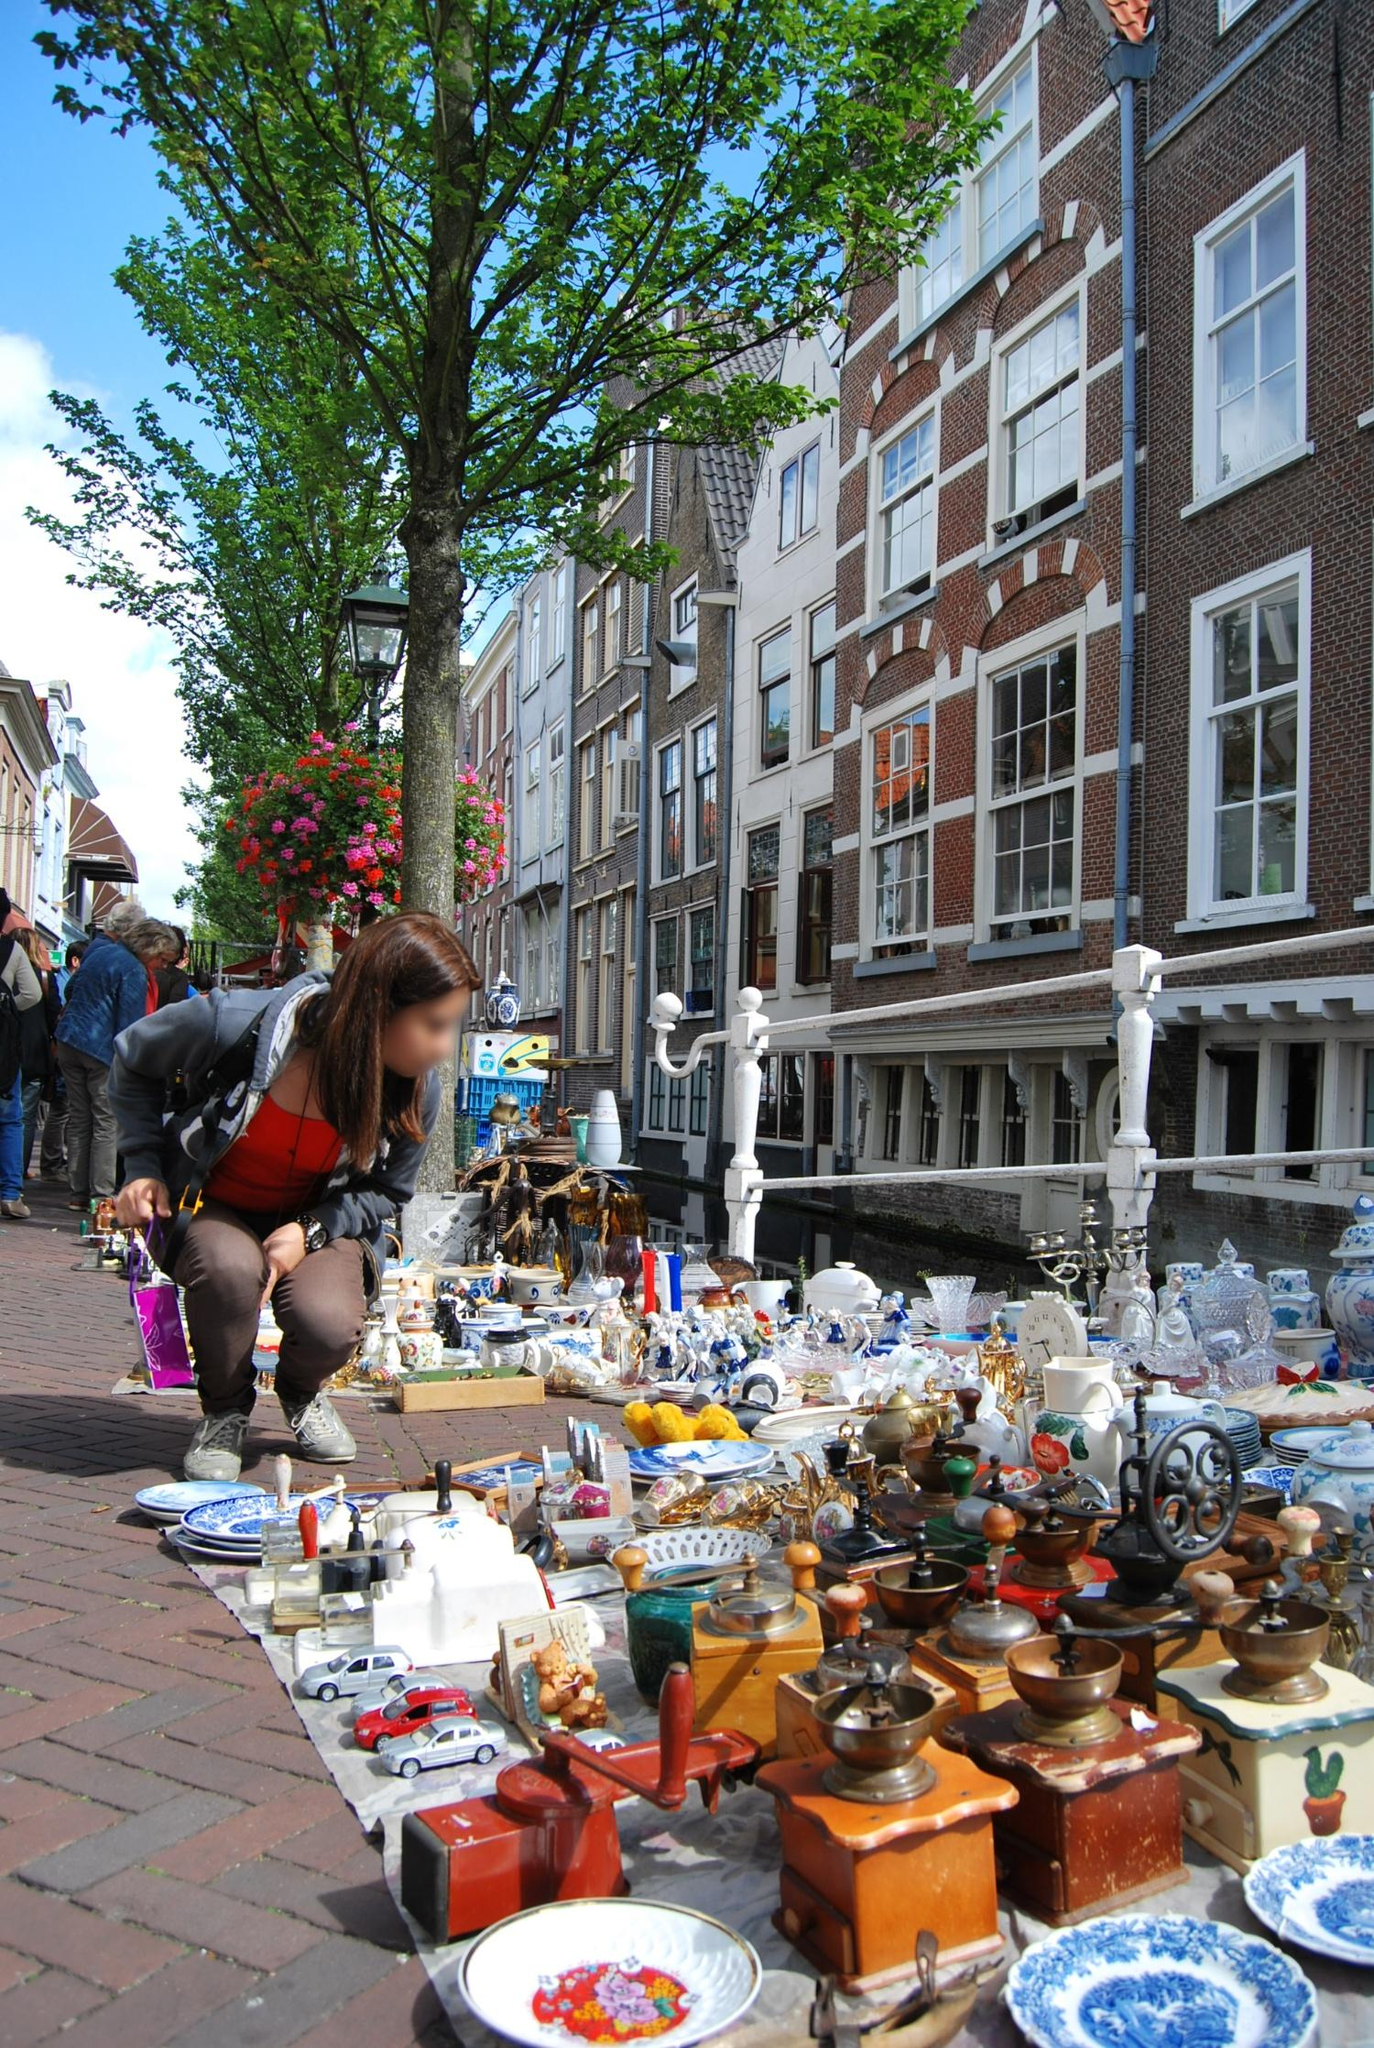Describe a day in the life of a vendor at this street market. A day in the life of a vendor at this street market in Amsterdam begins early in the morning. As the sun rises, they start setting up their stall, carefully arranging the various trinkets, antiques, and souvenirs to attract the attention of passing shoppers. Every item is given a spot where it can catch the light perfectly, drawing in curious customers.

Throughout the day, the vendor engages with a diverse mix of people — from locals looking for unique finds to tourists eager to take home a piece of Amsterdam. They share stories about their items, offer friendly bargaining, and enjoy the vibrant conversations that breathe life into the market. The vendor often takes moments to appreciate the lively atmosphere, the sounds of laughter, and the hum of activity surrounding them.

During quieter times, the vendor might chat with fellow stall-owners, exchange tips, and build a community within the market. Lunch is a quick, delicious bite from a nearby food stall, keeping them energized for the afternoon crowd. As the day winds down and the sun begins to set, they carefully pack up their unsold items, ensuring everything is secure for the next market day, and head home, satisfied with the day's work and interactions.  If you could interview one of the antique items on the market stall, what would it say about its journey? If I could interview one of the antique items on the market stall, let's say an old-fashioned coffee grinder, it would probably have a fascinating tale to tell. It might start by describing its origins, crafted in a small village workshop by an expert craftsman over a century ago. The coffee grinder was a prized possession in a quaint household, essential for every morning's brew.

It traveled across continents, carried by a family who emigrated in search of a better life, becoming a cherished heirloom. The grinder witnessed countless family moments, from early morning laughter to late-night conversations over coffee. Over the years, it saw the rise and fall of other appliances, each modern advancement making it feel more antique and precious.

Eventually, it ended up in an antique shop, where it was bought by a collector who marveled at its vintage charm and craftsmanship. The collector, appreciating its historic value, reluctantly parted with it, allowing it to continue its journey to the street market in Amsterdam. Here, it sits among other vintage curios, hoping to find another home where it can once again be part of new stories and memories. 